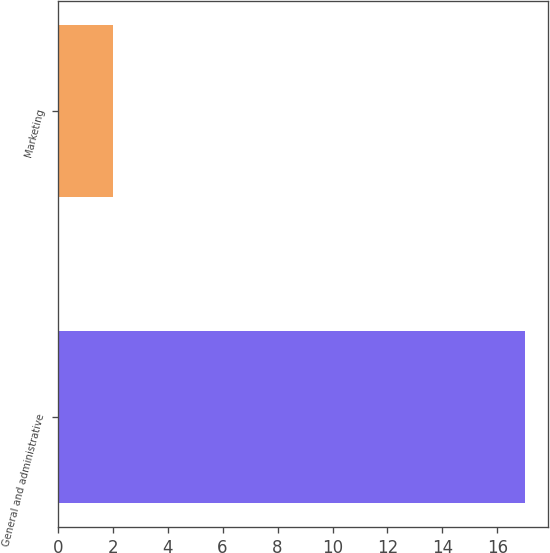Convert chart to OTSL. <chart><loc_0><loc_0><loc_500><loc_500><bar_chart><fcel>General and administrative<fcel>Marketing<nl><fcel>17<fcel>2<nl></chart> 